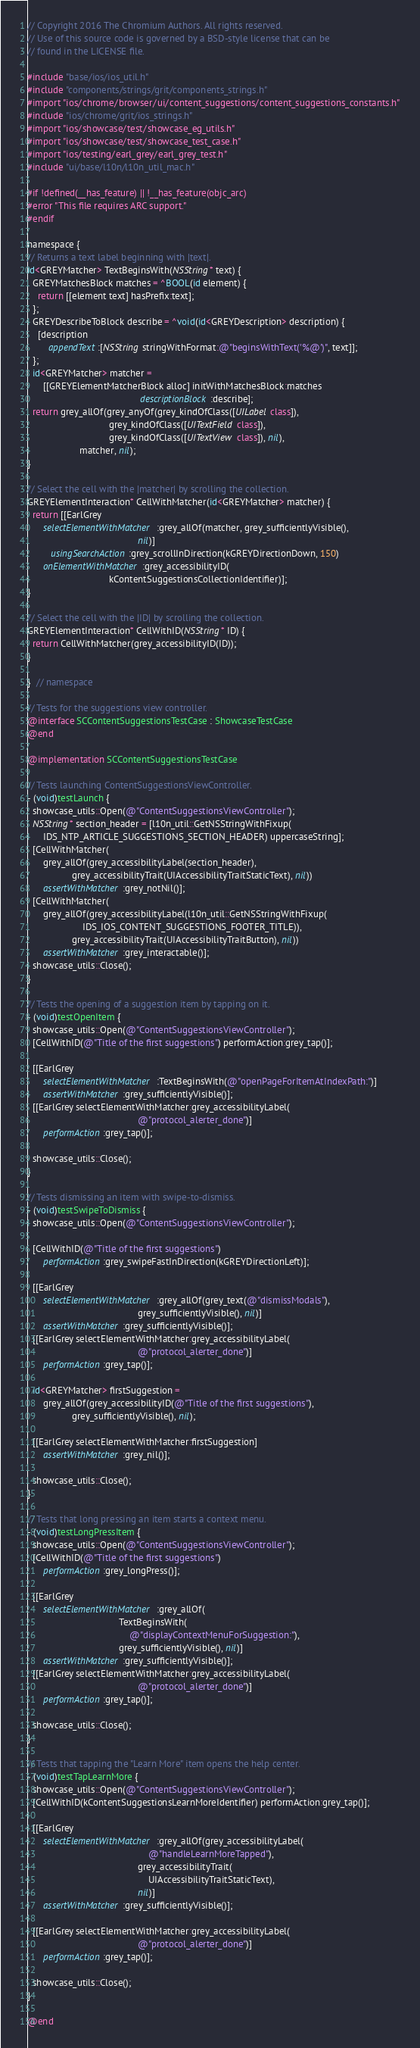Convert code to text. <code><loc_0><loc_0><loc_500><loc_500><_ObjectiveC_>// Copyright 2016 The Chromium Authors. All rights reserved.
// Use of this source code is governed by a BSD-style license that can be
// found in the LICENSE file.

#include "base/ios/ios_util.h"
#include "components/strings/grit/components_strings.h"
#import "ios/chrome/browser/ui/content_suggestions/content_suggestions_constants.h"
#include "ios/chrome/grit/ios_strings.h"
#import "ios/showcase/test/showcase_eg_utils.h"
#import "ios/showcase/test/showcase_test_case.h"
#import "ios/testing/earl_grey/earl_grey_test.h"
#include "ui/base/l10n/l10n_util_mac.h"

#if !defined(__has_feature) || !__has_feature(objc_arc)
#error "This file requires ARC support."
#endif

namespace {
// Returns a text label beginning with |text|.
id<GREYMatcher> TextBeginsWith(NSString* text) {
  GREYMatchesBlock matches = ^BOOL(id element) {
    return [[element text] hasPrefix:text];
  };
  GREYDescribeToBlock describe = ^void(id<GREYDescription> description) {
    [description
        appendText:[NSString stringWithFormat:@"beginsWithText('%@')", text]];
  };
  id<GREYMatcher> matcher =
      [[GREYElementMatcherBlock alloc] initWithMatchesBlock:matches
                                           descriptionBlock:describe];
  return grey_allOf(grey_anyOf(grey_kindOfClass([UILabel class]),
                               grey_kindOfClass([UITextField class]),
                               grey_kindOfClass([UITextView class]), nil),
                    matcher, nil);
}

// Select the cell with the |matcher| by scrolling the collection.
GREYElementInteraction* CellWithMatcher(id<GREYMatcher> matcher) {
  return [[EarlGrey
      selectElementWithMatcher:grey_allOf(matcher, grey_sufficientlyVisible(),
                                          nil)]
         usingSearchAction:grey_scrollInDirection(kGREYDirectionDown, 150)
      onElementWithMatcher:grey_accessibilityID(
                               kContentSuggestionsCollectionIdentifier)];
}

// Select the cell with the |ID| by scrolling the collection.
GREYElementInteraction* CellWithID(NSString* ID) {
  return CellWithMatcher(grey_accessibilityID(ID));
}

}  // namespace

// Tests for the suggestions view controller.
@interface SCContentSuggestionsTestCase : ShowcaseTestCase
@end

@implementation SCContentSuggestionsTestCase

// Tests launching ContentSuggestionsViewController.
- (void)testLaunch {
  showcase_utils::Open(@"ContentSuggestionsViewController");
  NSString* section_header = [l10n_util::GetNSStringWithFixup(
      IDS_NTP_ARTICLE_SUGGESTIONS_SECTION_HEADER) uppercaseString];
  [CellWithMatcher(
      grey_allOf(grey_accessibilityLabel(section_header),
                 grey_accessibilityTrait(UIAccessibilityTraitStaticText), nil))
      assertWithMatcher:grey_notNil()];
  [CellWithMatcher(
      grey_allOf(grey_accessibilityLabel(l10n_util::GetNSStringWithFixup(
                     IDS_IOS_CONTENT_SUGGESTIONS_FOOTER_TITLE)),
                 grey_accessibilityTrait(UIAccessibilityTraitButton), nil))
      assertWithMatcher:grey_interactable()];
  showcase_utils::Close();
}

// Tests the opening of a suggestion item by tapping on it.
- (void)testOpenItem {
  showcase_utils::Open(@"ContentSuggestionsViewController");
  [CellWithID(@"Title of the first suggestions") performAction:grey_tap()];

  [[EarlGrey
      selectElementWithMatcher:TextBeginsWith(@"openPageForItemAtIndexPath:")]
      assertWithMatcher:grey_sufficientlyVisible()];
  [[EarlGrey selectElementWithMatcher:grey_accessibilityLabel(
                                          @"protocol_alerter_done")]
      performAction:grey_tap()];

  showcase_utils::Close();
}

// Tests dismissing an item with swipe-to-dismiss.
- (void)testSwipeToDismiss {
  showcase_utils::Open(@"ContentSuggestionsViewController");

  [CellWithID(@"Title of the first suggestions")
      performAction:grey_swipeFastInDirection(kGREYDirectionLeft)];

  [[EarlGrey
      selectElementWithMatcher:grey_allOf(grey_text(@"dismissModals"),
                                          grey_sufficientlyVisible(), nil)]
      assertWithMatcher:grey_sufficientlyVisible()];
  [[EarlGrey selectElementWithMatcher:grey_accessibilityLabel(
                                          @"protocol_alerter_done")]
      performAction:grey_tap()];

  id<GREYMatcher> firstSuggestion =
      grey_allOf(grey_accessibilityID(@"Title of the first suggestions"),
                 grey_sufficientlyVisible(), nil);

  [[EarlGrey selectElementWithMatcher:firstSuggestion]
      assertWithMatcher:grey_nil()];

  showcase_utils::Close();
}

// Tests that long pressing an item starts a context menu.
- (void)testLongPressItem {
  showcase_utils::Open(@"ContentSuggestionsViewController");
  [CellWithID(@"Title of the first suggestions")
      performAction:grey_longPress()];

  [[EarlGrey
      selectElementWithMatcher:grey_allOf(
                                   TextBeginsWith(
                                       @"displayContextMenuForSuggestion:"),
                                   grey_sufficientlyVisible(), nil)]
      assertWithMatcher:grey_sufficientlyVisible()];
  [[EarlGrey selectElementWithMatcher:grey_accessibilityLabel(
                                          @"protocol_alerter_done")]
      performAction:grey_tap()];

  showcase_utils::Close();
}

// Tests that tapping the "Learn More" item opens the help center.
- (void)testTapLearnMore {
  showcase_utils::Open(@"ContentSuggestionsViewController");
  [CellWithID(kContentSuggestionsLearnMoreIdentifier) performAction:grey_tap()];

  [[EarlGrey
      selectElementWithMatcher:grey_allOf(grey_accessibilityLabel(
                                              @"handleLearnMoreTapped"),
                                          grey_accessibilityTrait(
                                              UIAccessibilityTraitStaticText),
                                          nil)]
      assertWithMatcher:grey_sufficientlyVisible()];

  [[EarlGrey selectElementWithMatcher:grey_accessibilityLabel(
                                          @"protocol_alerter_done")]
      performAction:grey_tap()];

  showcase_utils::Close();
}

@end
</code> 